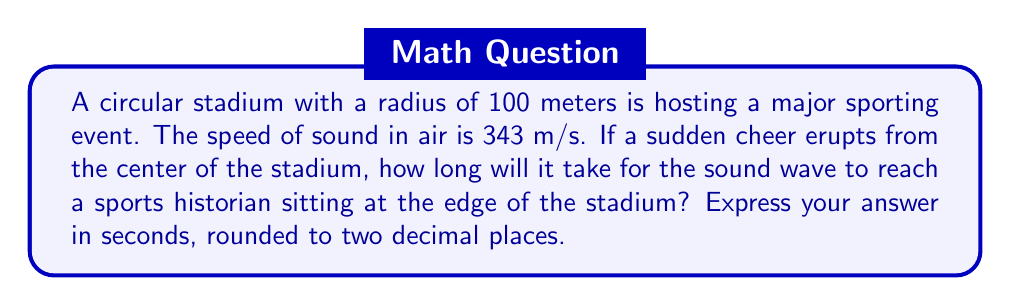Solve this math problem. To solve this problem, we need to use the wave equation for sound propagation. In this case, we're dealing with a simple radial propagation from the center of the stadium to its edge.

Step 1: Identify the relevant variables
- Radius of the stadium (distance traveled by the sound wave): $r = 100$ m
- Speed of sound in air: $v = 343$ m/s

Step 2: Use the wave equation to calculate the time
The wave equation for distance, speed, and time is:

$$ d = vt $$

Where:
$d$ is the distance traveled
$v$ is the velocity (speed) of the wave
$t$ is the time taken

We need to solve for $t$, so we rearrange the equation:

$$ t = \frac{d}{v} $$

Step 3: Substitute the known values
$$ t = \frac{100 \text{ m}}{343 \text{ m/s}} $$

Step 4: Calculate the result
$$ t \approx 0.2915 \text{ seconds} $$

Step 5: Round to two decimal places
$$ t \approx 0.29 \text{ seconds} $$
Answer: 0.29 seconds 